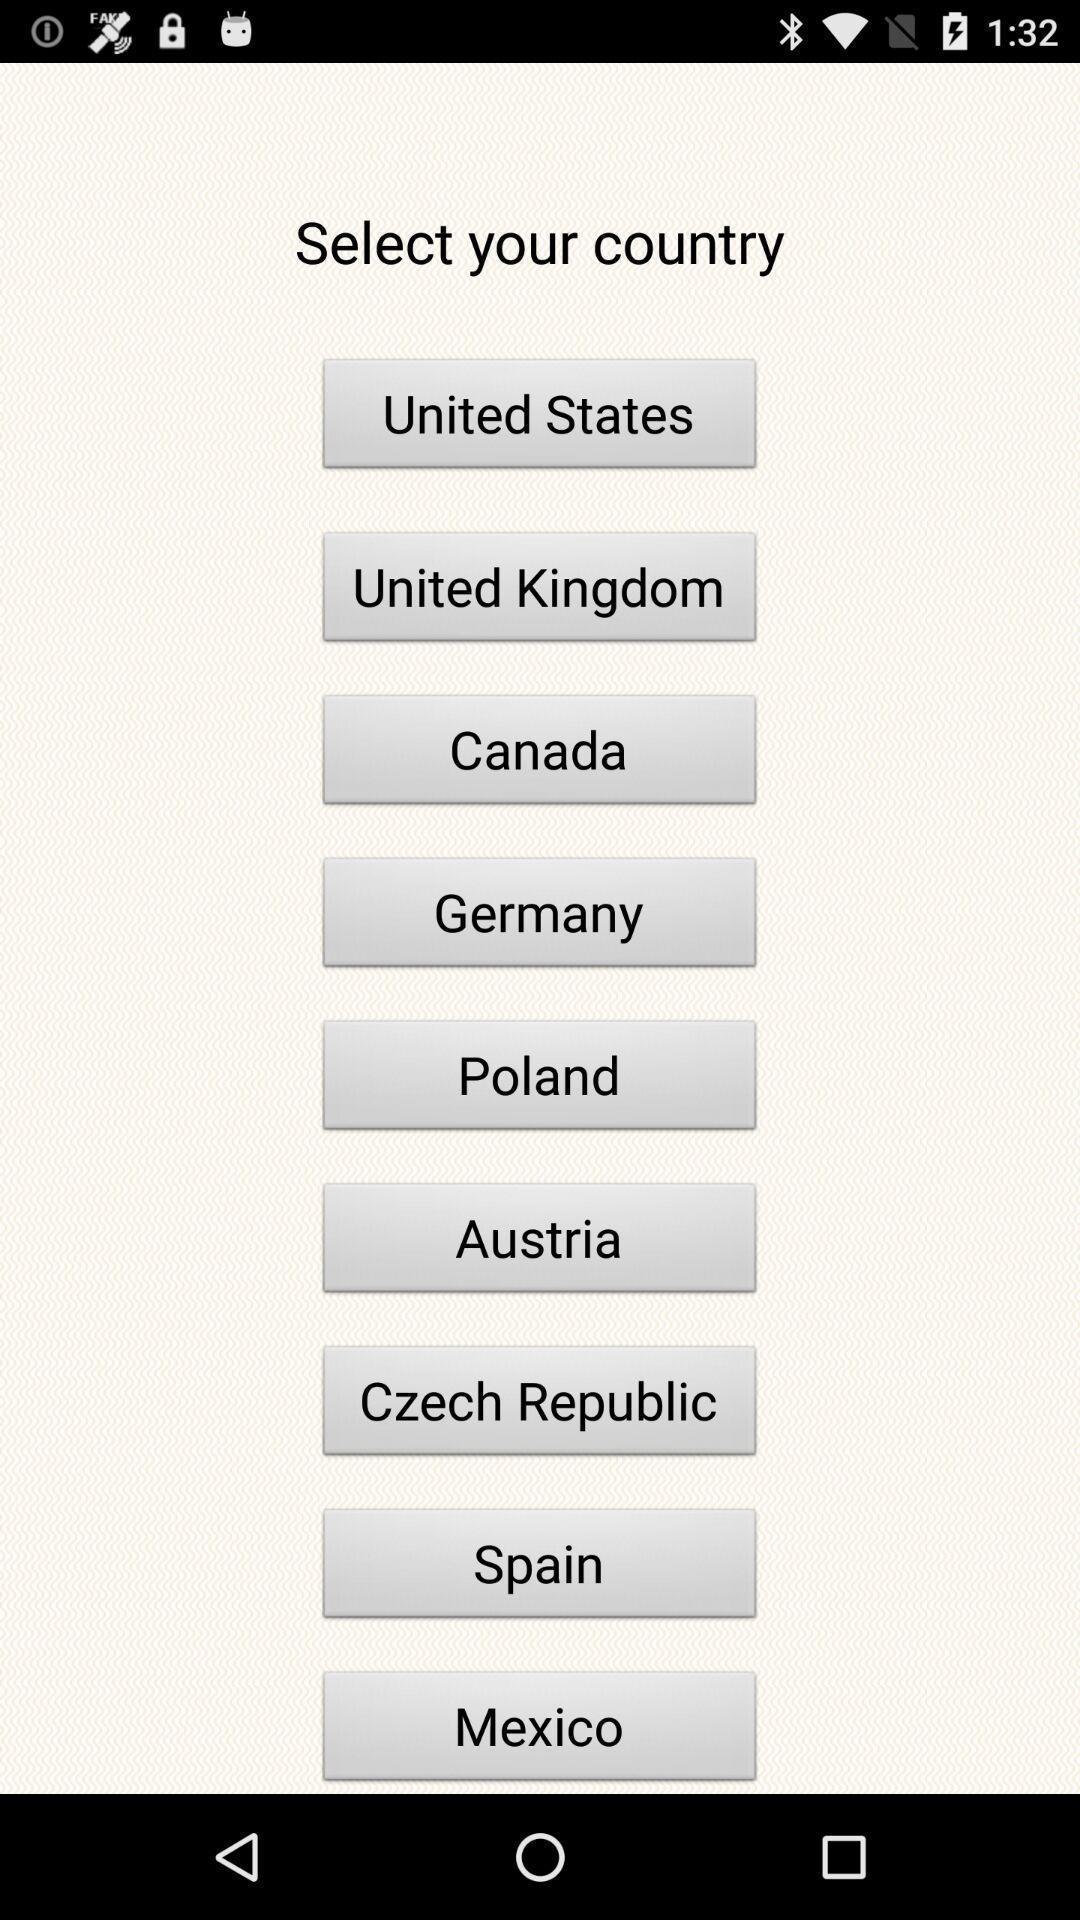Provide a description of this screenshot. Page to choose the country from the options given. 